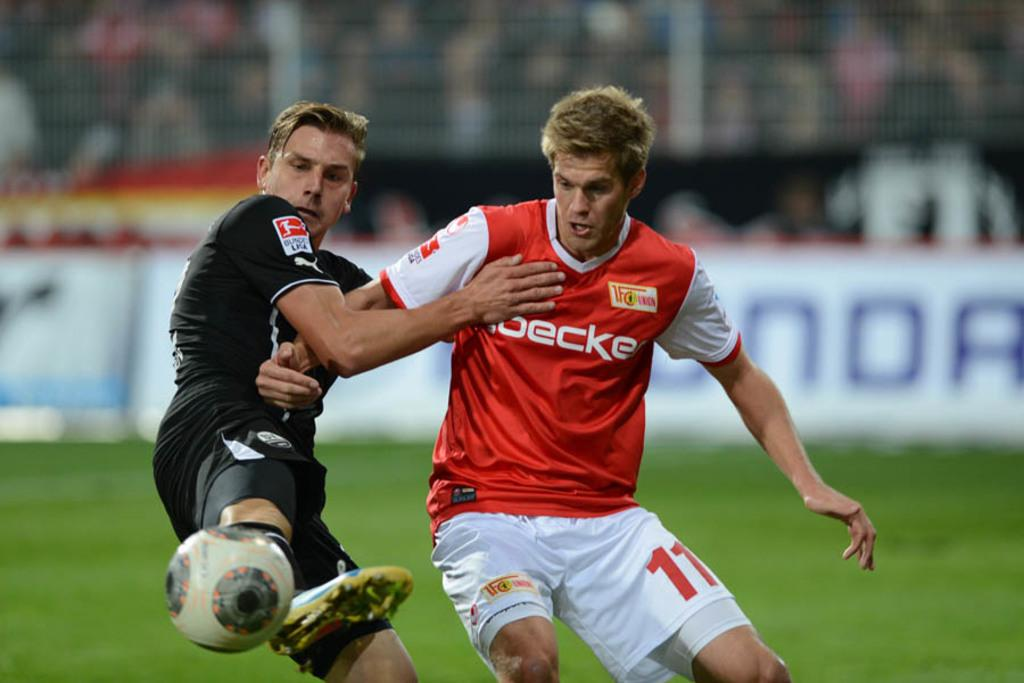What are the two people in the image doing? They are playing football. What object are they using to play? They are playing with a football. Can you describe the scene in the background? There are spectators in the background. What is the name of the kitten that is playing with the geese in the image? There is no kitten or geese present in the image; it features two people playing football. 